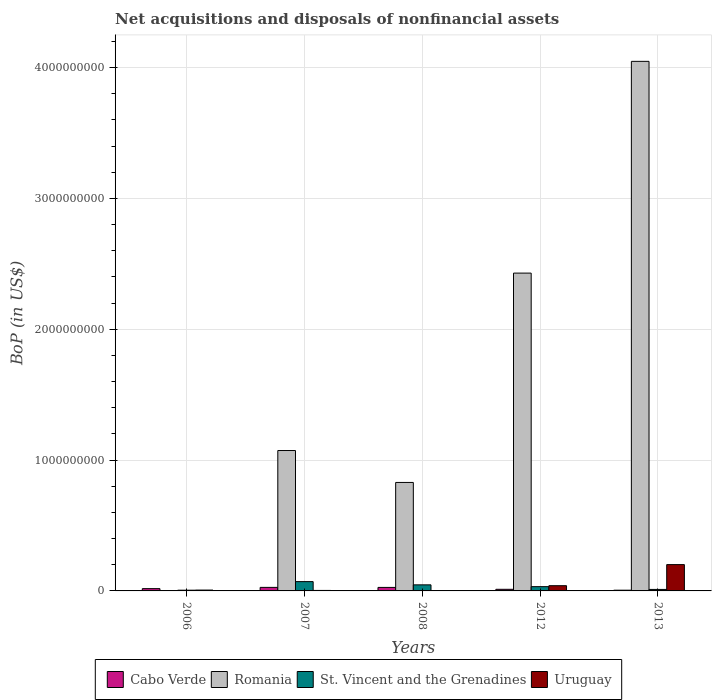How many groups of bars are there?
Your answer should be compact. 5. Are the number of bars on each tick of the X-axis equal?
Offer a very short reply. No. What is the label of the 1st group of bars from the left?
Your answer should be compact. 2006. What is the Balance of Payments in Uruguay in 2008?
Give a very brief answer. 2.14e+05. Across all years, what is the maximum Balance of Payments in Romania?
Provide a short and direct response. 4.05e+09. Across all years, what is the minimum Balance of Payments in Romania?
Ensure brevity in your answer.  0. In which year was the Balance of Payments in St. Vincent and the Grenadines maximum?
Provide a succinct answer. 2007. What is the total Balance of Payments in Romania in the graph?
Your answer should be compact. 8.38e+09. What is the difference between the Balance of Payments in Cabo Verde in 2008 and that in 2013?
Ensure brevity in your answer.  2.12e+07. What is the difference between the Balance of Payments in St. Vincent and the Grenadines in 2007 and the Balance of Payments in Cabo Verde in 2013?
Offer a very short reply. 6.56e+07. What is the average Balance of Payments in Uruguay per year?
Provide a short and direct response. 5.03e+07. In the year 2012, what is the difference between the Balance of Payments in Uruguay and Balance of Payments in Romania?
Make the answer very short. -2.39e+09. What is the ratio of the Balance of Payments in St. Vincent and the Grenadines in 2006 to that in 2012?
Offer a terse response. 0.17. What is the difference between the highest and the second highest Balance of Payments in Uruguay?
Offer a very short reply. 1.61e+08. What is the difference between the highest and the lowest Balance of Payments in Uruguay?
Provide a succinct answer. 2.01e+08. Is the sum of the Balance of Payments in Romania in 2007 and 2012 greater than the maximum Balance of Payments in Uruguay across all years?
Your answer should be very brief. Yes. How many bars are there?
Offer a very short reply. 19. Are all the bars in the graph horizontal?
Keep it short and to the point. No. How many years are there in the graph?
Provide a short and direct response. 5. What is the difference between two consecutive major ticks on the Y-axis?
Provide a short and direct response. 1.00e+09. Are the values on the major ticks of Y-axis written in scientific E-notation?
Ensure brevity in your answer.  No. Where does the legend appear in the graph?
Your answer should be compact. Bottom center. How many legend labels are there?
Your response must be concise. 4. How are the legend labels stacked?
Your answer should be very brief. Horizontal. What is the title of the graph?
Your answer should be very brief. Net acquisitions and disposals of nonfinancial assets. What is the label or title of the X-axis?
Give a very brief answer. Years. What is the label or title of the Y-axis?
Provide a short and direct response. BoP (in US$). What is the BoP (in US$) of Cabo Verde in 2006?
Your response must be concise. 1.75e+07. What is the BoP (in US$) in Romania in 2006?
Offer a very short reply. 0. What is the BoP (in US$) of St. Vincent and the Grenadines in 2006?
Offer a very short reply. 5.56e+06. What is the BoP (in US$) in Uruguay in 2006?
Offer a very short reply. 6.51e+06. What is the BoP (in US$) in Cabo Verde in 2007?
Ensure brevity in your answer.  2.70e+07. What is the BoP (in US$) of Romania in 2007?
Offer a terse response. 1.07e+09. What is the BoP (in US$) of St. Vincent and the Grenadines in 2007?
Offer a terse response. 7.11e+07. What is the BoP (in US$) of Uruguay in 2007?
Your response must be concise. 3.71e+06. What is the BoP (in US$) in Cabo Verde in 2008?
Provide a short and direct response. 2.67e+07. What is the BoP (in US$) of Romania in 2008?
Give a very brief answer. 8.29e+08. What is the BoP (in US$) in St. Vincent and the Grenadines in 2008?
Make the answer very short. 4.63e+07. What is the BoP (in US$) in Uruguay in 2008?
Your answer should be compact. 2.14e+05. What is the BoP (in US$) in Cabo Verde in 2012?
Offer a very short reply. 1.23e+07. What is the BoP (in US$) of Romania in 2012?
Your response must be concise. 2.43e+09. What is the BoP (in US$) of St. Vincent and the Grenadines in 2012?
Give a very brief answer. 3.26e+07. What is the BoP (in US$) in Uruguay in 2012?
Your answer should be very brief. 4.00e+07. What is the BoP (in US$) of Cabo Verde in 2013?
Give a very brief answer. 5.54e+06. What is the BoP (in US$) in Romania in 2013?
Your response must be concise. 4.05e+09. What is the BoP (in US$) of St. Vincent and the Grenadines in 2013?
Your response must be concise. 1.14e+07. What is the BoP (in US$) of Uruguay in 2013?
Your answer should be compact. 2.01e+08. Across all years, what is the maximum BoP (in US$) in Cabo Verde?
Offer a very short reply. 2.70e+07. Across all years, what is the maximum BoP (in US$) in Romania?
Offer a terse response. 4.05e+09. Across all years, what is the maximum BoP (in US$) of St. Vincent and the Grenadines?
Offer a very short reply. 7.11e+07. Across all years, what is the maximum BoP (in US$) of Uruguay?
Ensure brevity in your answer.  2.01e+08. Across all years, what is the minimum BoP (in US$) in Cabo Verde?
Provide a short and direct response. 5.54e+06. Across all years, what is the minimum BoP (in US$) of Romania?
Ensure brevity in your answer.  0. Across all years, what is the minimum BoP (in US$) in St. Vincent and the Grenadines?
Make the answer very short. 5.56e+06. Across all years, what is the minimum BoP (in US$) in Uruguay?
Offer a very short reply. 2.14e+05. What is the total BoP (in US$) in Cabo Verde in the graph?
Offer a very short reply. 8.91e+07. What is the total BoP (in US$) of Romania in the graph?
Provide a short and direct response. 8.38e+09. What is the total BoP (in US$) in St. Vincent and the Grenadines in the graph?
Your answer should be very brief. 1.67e+08. What is the total BoP (in US$) in Uruguay in the graph?
Offer a terse response. 2.52e+08. What is the difference between the BoP (in US$) of Cabo Verde in 2006 and that in 2007?
Your answer should be compact. -9.56e+06. What is the difference between the BoP (in US$) in St. Vincent and the Grenadines in 2006 and that in 2007?
Provide a short and direct response. -6.55e+07. What is the difference between the BoP (in US$) in Uruguay in 2006 and that in 2007?
Your answer should be very brief. 2.80e+06. What is the difference between the BoP (in US$) of Cabo Verde in 2006 and that in 2008?
Offer a terse response. -9.28e+06. What is the difference between the BoP (in US$) of St. Vincent and the Grenadines in 2006 and that in 2008?
Make the answer very short. -4.08e+07. What is the difference between the BoP (in US$) of Uruguay in 2006 and that in 2008?
Ensure brevity in your answer.  6.29e+06. What is the difference between the BoP (in US$) of Cabo Verde in 2006 and that in 2012?
Offer a very short reply. 5.16e+06. What is the difference between the BoP (in US$) in St. Vincent and the Grenadines in 2006 and that in 2012?
Keep it short and to the point. -2.71e+07. What is the difference between the BoP (in US$) of Uruguay in 2006 and that in 2012?
Give a very brief answer. -3.35e+07. What is the difference between the BoP (in US$) of Cabo Verde in 2006 and that in 2013?
Give a very brief answer. 1.19e+07. What is the difference between the BoP (in US$) in St. Vincent and the Grenadines in 2006 and that in 2013?
Offer a terse response. -5.85e+06. What is the difference between the BoP (in US$) of Uruguay in 2006 and that in 2013?
Make the answer very short. -1.95e+08. What is the difference between the BoP (in US$) of Cabo Verde in 2007 and that in 2008?
Make the answer very short. 2.85e+05. What is the difference between the BoP (in US$) in Romania in 2007 and that in 2008?
Keep it short and to the point. 2.44e+08. What is the difference between the BoP (in US$) in St. Vincent and the Grenadines in 2007 and that in 2008?
Ensure brevity in your answer.  2.47e+07. What is the difference between the BoP (in US$) in Uruguay in 2007 and that in 2008?
Provide a succinct answer. 3.49e+06. What is the difference between the BoP (in US$) in Cabo Verde in 2007 and that in 2012?
Make the answer very short. 1.47e+07. What is the difference between the BoP (in US$) in Romania in 2007 and that in 2012?
Offer a very short reply. -1.36e+09. What is the difference between the BoP (in US$) in St. Vincent and the Grenadines in 2007 and that in 2012?
Offer a very short reply. 3.85e+07. What is the difference between the BoP (in US$) of Uruguay in 2007 and that in 2012?
Provide a succinct answer. -3.63e+07. What is the difference between the BoP (in US$) of Cabo Verde in 2007 and that in 2013?
Ensure brevity in your answer.  2.15e+07. What is the difference between the BoP (in US$) in Romania in 2007 and that in 2013?
Give a very brief answer. -2.97e+09. What is the difference between the BoP (in US$) of St. Vincent and the Grenadines in 2007 and that in 2013?
Your answer should be compact. 5.97e+07. What is the difference between the BoP (in US$) of Uruguay in 2007 and that in 2013?
Ensure brevity in your answer.  -1.97e+08. What is the difference between the BoP (in US$) in Cabo Verde in 2008 and that in 2012?
Your answer should be compact. 1.44e+07. What is the difference between the BoP (in US$) of Romania in 2008 and that in 2012?
Your answer should be very brief. -1.60e+09. What is the difference between the BoP (in US$) in St. Vincent and the Grenadines in 2008 and that in 2012?
Your response must be concise. 1.37e+07. What is the difference between the BoP (in US$) in Uruguay in 2008 and that in 2012?
Your response must be concise. -3.98e+07. What is the difference between the BoP (in US$) in Cabo Verde in 2008 and that in 2013?
Keep it short and to the point. 2.12e+07. What is the difference between the BoP (in US$) in Romania in 2008 and that in 2013?
Provide a succinct answer. -3.22e+09. What is the difference between the BoP (in US$) of St. Vincent and the Grenadines in 2008 and that in 2013?
Give a very brief answer. 3.49e+07. What is the difference between the BoP (in US$) in Uruguay in 2008 and that in 2013?
Offer a terse response. -2.01e+08. What is the difference between the BoP (in US$) in Cabo Verde in 2012 and that in 2013?
Provide a short and direct response. 6.77e+06. What is the difference between the BoP (in US$) of Romania in 2012 and that in 2013?
Give a very brief answer. -1.62e+09. What is the difference between the BoP (in US$) in St. Vincent and the Grenadines in 2012 and that in 2013?
Your response must be concise. 2.12e+07. What is the difference between the BoP (in US$) of Uruguay in 2012 and that in 2013?
Give a very brief answer. -1.61e+08. What is the difference between the BoP (in US$) in Cabo Verde in 2006 and the BoP (in US$) in Romania in 2007?
Give a very brief answer. -1.06e+09. What is the difference between the BoP (in US$) of Cabo Verde in 2006 and the BoP (in US$) of St. Vincent and the Grenadines in 2007?
Make the answer very short. -5.36e+07. What is the difference between the BoP (in US$) in Cabo Verde in 2006 and the BoP (in US$) in Uruguay in 2007?
Ensure brevity in your answer.  1.38e+07. What is the difference between the BoP (in US$) of St. Vincent and the Grenadines in 2006 and the BoP (in US$) of Uruguay in 2007?
Offer a terse response. 1.85e+06. What is the difference between the BoP (in US$) in Cabo Verde in 2006 and the BoP (in US$) in Romania in 2008?
Your answer should be compact. -8.12e+08. What is the difference between the BoP (in US$) of Cabo Verde in 2006 and the BoP (in US$) of St. Vincent and the Grenadines in 2008?
Provide a succinct answer. -2.89e+07. What is the difference between the BoP (in US$) in Cabo Verde in 2006 and the BoP (in US$) in Uruguay in 2008?
Make the answer very short. 1.73e+07. What is the difference between the BoP (in US$) in St. Vincent and the Grenadines in 2006 and the BoP (in US$) in Uruguay in 2008?
Give a very brief answer. 5.35e+06. What is the difference between the BoP (in US$) in Cabo Verde in 2006 and the BoP (in US$) in Romania in 2012?
Your answer should be very brief. -2.41e+09. What is the difference between the BoP (in US$) in Cabo Verde in 2006 and the BoP (in US$) in St. Vincent and the Grenadines in 2012?
Keep it short and to the point. -1.51e+07. What is the difference between the BoP (in US$) of Cabo Verde in 2006 and the BoP (in US$) of Uruguay in 2012?
Ensure brevity in your answer.  -2.25e+07. What is the difference between the BoP (in US$) in St. Vincent and the Grenadines in 2006 and the BoP (in US$) in Uruguay in 2012?
Your answer should be compact. -3.44e+07. What is the difference between the BoP (in US$) in Cabo Verde in 2006 and the BoP (in US$) in Romania in 2013?
Your answer should be compact. -4.03e+09. What is the difference between the BoP (in US$) of Cabo Verde in 2006 and the BoP (in US$) of St. Vincent and the Grenadines in 2013?
Provide a short and direct response. 6.06e+06. What is the difference between the BoP (in US$) in Cabo Verde in 2006 and the BoP (in US$) in Uruguay in 2013?
Keep it short and to the point. -1.84e+08. What is the difference between the BoP (in US$) of St. Vincent and the Grenadines in 2006 and the BoP (in US$) of Uruguay in 2013?
Your answer should be compact. -1.96e+08. What is the difference between the BoP (in US$) of Cabo Verde in 2007 and the BoP (in US$) of Romania in 2008?
Provide a succinct answer. -8.02e+08. What is the difference between the BoP (in US$) of Cabo Verde in 2007 and the BoP (in US$) of St. Vincent and the Grenadines in 2008?
Give a very brief answer. -1.93e+07. What is the difference between the BoP (in US$) in Cabo Verde in 2007 and the BoP (in US$) in Uruguay in 2008?
Make the answer very short. 2.68e+07. What is the difference between the BoP (in US$) of Romania in 2007 and the BoP (in US$) of St. Vincent and the Grenadines in 2008?
Give a very brief answer. 1.03e+09. What is the difference between the BoP (in US$) in Romania in 2007 and the BoP (in US$) in Uruguay in 2008?
Make the answer very short. 1.07e+09. What is the difference between the BoP (in US$) of St. Vincent and the Grenadines in 2007 and the BoP (in US$) of Uruguay in 2008?
Provide a short and direct response. 7.09e+07. What is the difference between the BoP (in US$) in Cabo Verde in 2007 and the BoP (in US$) in Romania in 2012?
Your answer should be compact. -2.40e+09. What is the difference between the BoP (in US$) in Cabo Verde in 2007 and the BoP (in US$) in St. Vincent and the Grenadines in 2012?
Make the answer very short. -5.58e+06. What is the difference between the BoP (in US$) in Cabo Verde in 2007 and the BoP (in US$) in Uruguay in 2012?
Your answer should be very brief. -1.30e+07. What is the difference between the BoP (in US$) of Romania in 2007 and the BoP (in US$) of St. Vincent and the Grenadines in 2012?
Make the answer very short. 1.04e+09. What is the difference between the BoP (in US$) in Romania in 2007 and the BoP (in US$) in Uruguay in 2012?
Make the answer very short. 1.03e+09. What is the difference between the BoP (in US$) in St. Vincent and the Grenadines in 2007 and the BoP (in US$) in Uruguay in 2012?
Your response must be concise. 3.11e+07. What is the difference between the BoP (in US$) of Cabo Verde in 2007 and the BoP (in US$) of Romania in 2013?
Make the answer very short. -4.02e+09. What is the difference between the BoP (in US$) in Cabo Verde in 2007 and the BoP (in US$) in St. Vincent and the Grenadines in 2013?
Your response must be concise. 1.56e+07. What is the difference between the BoP (in US$) in Cabo Verde in 2007 and the BoP (in US$) in Uruguay in 2013?
Give a very brief answer. -1.74e+08. What is the difference between the BoP (in US$) of Romania in 2007 and the BoP (in US$) of St. Vincent and the Grenadines in 2013?
Ensure brevity in your answer.  1.06e+09. What is the difference between the BoP (in US$) of Romania in 2007 and the BoP (in US$) of Uruguay in 2013?
Keep it short and to the point. 8.72e+08. What is the difference between the BoP (in US$) in St. Vincent and the Grenadines in 2007 and the BoP (in US$) in Uruguay in 2013?
Your response must be concise. -1.30e+08. What is the difference between the BoP (in US$) in Cabo Verde in 2008 and the BoP (in US$) in Romania in 2012?
Give a very brief answer. -2.40e+09. What is the difference between the BoP (in US$) of Cabo Verde in 2008 and the BoP (in US$) of St. Vincent and the Grenadines in 2012?
Give a very brief answer. -5.87e+06. What is the difference between the BoP (in US$) of Cabo Verde in 2008 and the BoP (in US$) of Uruguay in 2012?
Provide a short and direct response. -1.33e+07. What is the difference between the BoP (in US$) in Romania in 2008 and the BoP (in US$) in St. Vincent and the Grenadines in 2012?
Offer a terse response. 7.96e+08. What is the difference between the BoP (in US$) in Romania in 2008 and the BoP (in US$) in Uruguay in 2012?
Give a very brief answer. 7.89e+08. What is the difference between the BoP (in US$) in St. Vincent and the Grenadines in 2008 and the BoP (in US$) in Uruguay in 2012?
Provide a short and direct response. 6.34e+06. What is the difference between the BoP (in US$) of Cabo Verde in 2008 and the BoP (in US$) of Romania in 2013?
Your response must be concise. -4.02e+09. What is the difference between the BoP (in US$) of Cabo Verde in 2008 and the BoP (in US$) of St. Vincent and the Grenadines in 2013?
Make the answer very short. 1.53e+07. What is the difference between the BoP (in US$) in Cabo Verde in 2008 and the BoP (in US$) in Uruguay in 2013?
Make the answer very short. -1.74e+08. What is the difference between the BoP (in US$) in Romania in 2008 and the BoP (in US$) in St. Vincent and the Grenadines in 2013?
Provide a short and direct response. 8.18e+08. What is the difference between the BoP (in US$) of Romania in 2008 and the BoP (in US$) of Uruguay in 2013?
Provide a short and direct response. 6.28e+08. What is the difference between the BoP (in US$) in St. Vincent and the Grenadines in 2008 and the BoP (in US$) in Uruguay in 2013?
Offer a terse response. -1.55e+08. What is the difference between the BoP (in US$) in Cabo Verde in 2012 and the BoP (in US$) in Romania in 2013?
Make the answer very short. -4.04e+09. What is the difference between the BoP (in US$) of Cabo Verde in 2012 and the BoP (in US$) of St. Vincent and the Grenadines in 2013?
Provide a succinct answer. 9.00e+05. What is the difference between the BoP (in US$) of Cabo Verde in 2012 and the BoP (in US$) of Uruguay in 2013?
Your response must be concise. -1.89e+08. What is the difference between the BoP (in US$) in Romania in 2012 and the BoP (in US$) in St. Vincent and the Grenadines in 2013?
Ensure brevity in your answer.  2.42e+09. What is the difference between the BoP (in US$) of Romania in 2012 and the BoP (in US$) of Uruguay in 2013?
Your answer should be compact. 2.23e+09. What is the difference between the BoP (in US$) in St. Vincent and the Grenadines in 2012 and the BoP (in US$) in Uruguay in 2013?
Your response must be concise. -1.69e+08. What is the average BoP (in US$) in Cabo Verde per year?
Offer a very short reply. 1.78e+07. What is the average BoP (in US$) of Romania per year?
Provide a short and direct response. 1.68e+09. What is the average BoP (in US$) of St. Vincent and the Grenadines per year?
Keep it short and to the point. 3.34e+07. What is the average BoP (in US$) of Uruguay per year?
Your answer should be very brief. 5.03e+07. In the year 2006, what is the difference between the BoP (in US$) in Cabo Verde and BoP (in US$) in St. Vincent and the Grenadines?
Provide a short and direct response. 1.19e+07. In the year 2006, what is the difference between the BoP (in US$) in Cabo Verde and BoP (in US$) in Uruguay?
Keep it short and to the point. 1.10e+07. In the year 2006, what is the difference between the BoP (in US$) in St. Vincent and the Grenadines and BoP (in US$) in Uruguay?
Keep it short and to the point. -9.43e+05. In the year 2007, what is the difference between the BoP (in US$) in Cabo Verde and BoP (in US$) in Romania?
Your response must be concise. -1.05e+09. In the year 2007, what is the difference between the BoP (in US$) in Cabo Verde and BoP (in US$) in St. Vincent and the Grenadines?
Provide a succinct answer. -4.41e+07. In the year 2007, what is the difference between the BoP (in US$) in Cabo Verde and BoP (in US$) in Uruguay?
Your answer should be very brief. 2.33e+07. In the year 2007, what is the difference between the BoP (in US$) of Romania and BoP (in US$) of St. Vincent and the Grenadines?
Offer a very short reply. 1.00e+09. In the year 2007, what is the difference between the BoP (in US$) in Romania and BoP (in US$) in Uruguay?
Offer a very short reply. 1.07e+09. In the year 2007, what is the difference between the BoP (in US$) of St. Vincent and the Grenadines and BoP (in US$) of Uruguay?
Offer a very short reply. 6.74e+07. In the year 2008, what is the difference between the BoP (in US$) in Cabo Verde and BoP (in US$) in Romania?
Give a very brief answer. -8.02e+08. In the year 2008, what is the difference between the BoP (in US$) of Cabo Verde and BoP (in US$) of St. Vincent and the Grenadines?
Your answer should be very brief. -1.96e+07. In the year 2008, what is the difference between the BoP (in US$) of Cabo Verde and BoP (in US$) of Uruguay?
Offer a terse response. 2.65e+07. In the year 2008, what is the difference between the BoP (in US$) in Romania and BoP (in US$) in St. Vincent and the Grenadines?
Your answer should be very brief. 7.83e+08. In the year 2008, what is the difference between the BoP (in US$) of Romania and BoP (in US$) of Uruguay?
Your answer should be very brief. 8.29e+08. In the year 2008, what is the difference between the BoP (in US$) of St. Vincent and the Grenadines and BoP (in US$) of Uruguay?
Your answer should be compact. 4.61e+07. In the year 2012, what is the difference between the BoP (in US$) in Cabo Verde and BoP (in US$) in Romania?
Keep it short and to the point. -2.42e+09. In the year 2012, what is the difference between the BoP (in US$) of Cabo Verde and BoP (in US$) of St. Vincent and the Grenadines?
Give a very brief answer. -2.03e+07. In the year 2012, what is the difference between the BoP (in US$) in Cabo Verde and BoP (in US$) in Uruguay?
Offer a very short reply. -2.77e+07. In the year 2012, what is the difference between the BoP (in US$) in Romania and BoP (in US$) in St. Vincent and the Grenadines?
Ensure brevity in your answer.  2.40e+09. In the year 2012, what is the difference between the BoP (in US$) of Romania and BoP (in US$) of Uruguay?
Provide a short and direct response. 2.39e+09. In the year 2012, what is the difference between the BoP (in US$) in St. Vincent and the Grenadines and BoP (in US$) in Uruguay?
Make the answer very short. -7.38e+06. In the year 2013, what is the difference between the BoP (in US$) in Cabo Verde and BoP (in US$) in Romania?
Ensure brevity in your answer.  -4.04e+09. In the year 2013, what is the difference between the BoP (in US$) in Cabo Verde and BoP (in US$) in St. Vincent and the Grenadines?
Your answer should be compact. -5.88e+06. In the year 2013, what is the difference between the BoP (in US$) in Cabo Verde and BoP (in US$) in Uruguay?
Your response must be concise. -1.96e+08. In the year 2013, what is the difference between the BoP (in US$) of Romania and BoP (in US$) of St. Vincent and the Grenadines?
Make the answer very short. 4.04e+09. In the year 2013, what is the difference between the BoP (in US$) of Romania and BoP (in US$) of Uruguay?
Your response must be concise. 3.85e+09. In the year 2013, what is the difference between the BoP (in US$) of St. Vincent and the Grenadines and BoP (in US$) of Uruguay?
Offer a very short reply. -1.90e+08. What is the ratio of the BoP (in US$) of Cabo Verde in 2006 to that in 2007?
Ensure brevity in your answer.  0.65. What is the ratio of the BoP (in US$) of St. Vincent and the Grenadines in 2006 to that in 2007?
Provide a short and direct response. 0.08. What is the ratio of the BoP (in US$) in Uruguay in 2006 to that in 2007?
Ensure brevity in your answer.  1.75. What is the ratio of the BoP (in US$) in Cabo Verde in 2006 to that in 2008?
Make the answer very short. 0.65. What is the ratio of the BoP (in US$) of St. Vincent and the Grenadines in 2006 to that in 2008?
Your answer should be compact. 0.12. What is the ratio of the BoP (in US$) in Uruguay in 2006 to that in 2008?
Offer a terse response. 30.4. What is the ratio of the BoP (in US$) of Cabo Verde in 2006 to that in 2012?
Your answer should be very brief. 1.42. What is the ratio of the BoP (in US$) in St. Vincent and the Grenadines in 2006 to that in 2012?
Your answer should be compact. 0.17. What is the ratio of the BoP (in US$) in Uruguay in 2006 to that in 2012?
Provide a short and direct response. 0.16. What is the ratio of the BoP (in US$) in Cabo Verde in 2006 to that in 2013?
Your response must be concise. 3.15. What is the ratio of the BoP (in US$) of St. Vincent and the Grenadines in 2006 to that in 2013?
Make the answer very short. 0.49. What is the ratio of the BoP (in US$) of Uruguay in 2006 to that in 2013?
Your answer should be compact. 0.03. What is the ratio of the BoP (in US$) of Cabo Verde in 2007 to that in 2008?
Your answer should be very brief. 1.01. What is the ratio of the BoP (in US$) in Romania in 2007 to that in 2008?
Your answer should be compact. 1.29. What is the ratio of the BoP (in US$) of St. Vincent and the Grenadines in 2007 to that in 2008?
Your answer should be very brief. 1.53. What is the ratio of the BoP (in US$) in Uruguay in 2007 to that in 2008?
Provide a succinct answer. 17.33. What is the ratio of the BoP (in US$) of Cabo Verde in 2007 to that in 2012?
Offer a very short reply. 2.19. What is the ratio of the BoP (in US$) of Romania in 2007 to that in 2012?
Your answer should be compact. 0.44. What is the ratio of the BoP (in US$) in St. Vincent and the Grenadines in 2007 to that in 2012?
Make the answer very short. 2.18. What is the ratio of the BoP (in US$) in Uruguay in 2007 to that in 2012?
Offer a very short reply. 0.09. What is the ratio of the BoP (in US$) in Cabo Verde in 2007 to that in 2013?
Provide a succinct answer. 4.88. What is the ratio of the BoP (in US$) of Romania in 2007 to that in 2013?
Ensure brevity in your answer.  0.27. What is the ratio of the BoP (in US$) in St. Vincent and the Grenadines in 2007 to that in 2013?
Provide a short and direct response. 6.23. What is the ratio of the BoP (in US$) of Uruguay in 2007 to that in 2013?
Your answer should be very brief. 0.02. What is the ratio of the BoP (in US$) in Cabo Verde in 2008 to that in 2012?
Provide a succinct answer. 2.17. What is the ratio of the BoP (in US$) of Romania in 2008 to that in 2012?
Keep it short and to the point. 0.34. What is the ratio of the BoP (in US$) in St. Vincent and the Grenadines in 2008 to that in 2012?
Keep it short and to the point. 1.42. What is the ratio of the BoP (in US$) of Uruguay in 2008 to that in 2012?
Ensure brevity in your answer.  0.01. What is the ratio of the BoP (in US$) of Cabo Verde in 2008 to that in 2013?
Your response must be concise. 4.83. What is the ratio of the BoP (in US$) of Romania in 2008 to that in 2013?
Your response must be concise. 0.2. What is the ratio of the BoP (in US$) in St. Vincent and the Grenadines in 2008 to that in 2013?
Give a very brief answer. 4.06. What is the ratio of the BoP (in US$) in Uruguay in 2008 to that in 2013?
Provide a short and direct response. 0. What is the ratio of the BoP (in US$) of Cabo Verde in 2012 to that in 2013?
Your response must be concise. 2.22. What is the ratio of the BoP (in US$) of Romania in 2012 to that in 2013?
Offer a terse response. 0.6. What is the ratio of the BoP (in US$) in St. Vincent and the Grenadines in 2012 to that in 2013?
Make the answer very short. 2.86. What is the ratio of the BoP (in US$) of Uruguay in 2012 to that in 2013?
Offer a terse response. 0.2. What is the difference between the highest and the second highest BoP (in US$) of Cabo Verde?
Ensure brevity in your answer.  2.85e+05. What is the difference between the highest and the second highest BoP (in US$) of Romania?
Give a very brief answer. 1.62e+09. What is the difference between the highest and the second highest BoP (in US$) of St. Vincent and the Grenadines?
Offer a very short reply. 2.47e+07. What is the difference between the highest and the second highest BoP (in US$) of Uruguay?
Your response must be concise. 1.61e+08. What is the difference between the highest and the lowest BoP (in US$) of Cabo Verde?
Offer a very short reply. 2.15e+07. What is the difference between the highest and the lowest BoP (in US$) in Romania?
Your answer should be compact. 4.05e+09. What is the difference between the highest and the lowest BoP (in US$) in St. Vincent and the Grenadines?
Your answer should be compact. 6.55e+07. What is the difference between the highest and the lowest BoP (in US$) of Uruguay?
Your response must be concise. 2.01e+08. 